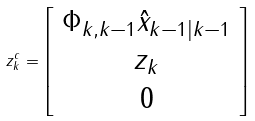Convert formula to latex. <formula><loc_0><loc_0><loc_500><loc_500>z _ { k } ^ { c } = \left [ \begin{array} { c } \Phi _ { k , k - 1 } \hat { x } _ { k - 1 | k - 1 } \\ z _ { k } \\ 0 \end{array} \right ]</formula> 